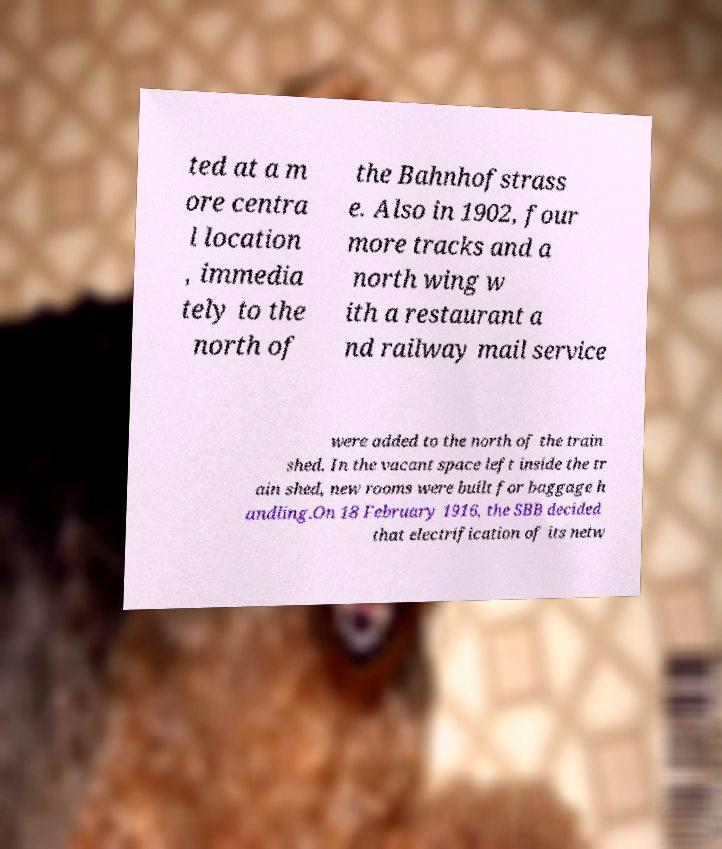I need the written content from this picture converted into text. Can you do that? ted at a m ore centra l location , immedia tely to the north of the Bahnhofstrass e. Also in 1902, four more tracks and a north wing w ith a restaurant a nd railway mail service were added to the north of the train shed. In the vacant space left inside the tr ain shed, new rooms were built for baggage h andling.On 18 February 1916, the SBB decided that electrification of its netw 